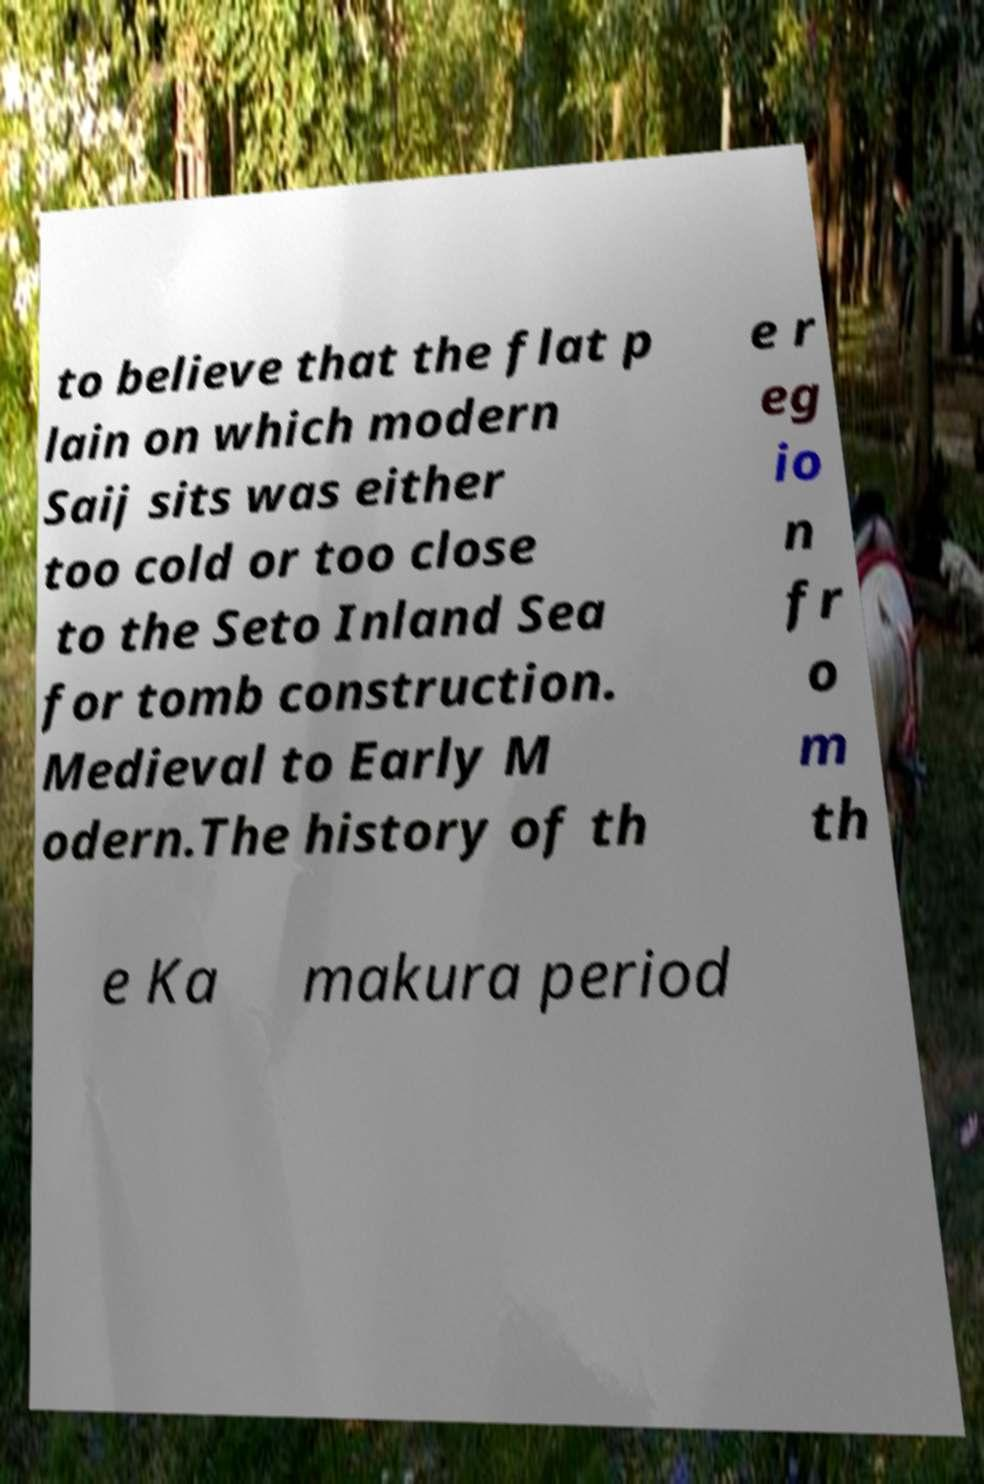Could you assist in decoding the text presented in this image and type it out clearly? to believe that the flat p lain on which modern Saij sits was either too cold or too close to the Seto Inland Sea for tomb construction. Medieval to Early M odern.The history of th e r eg io n fr o m th e Ka makura period 